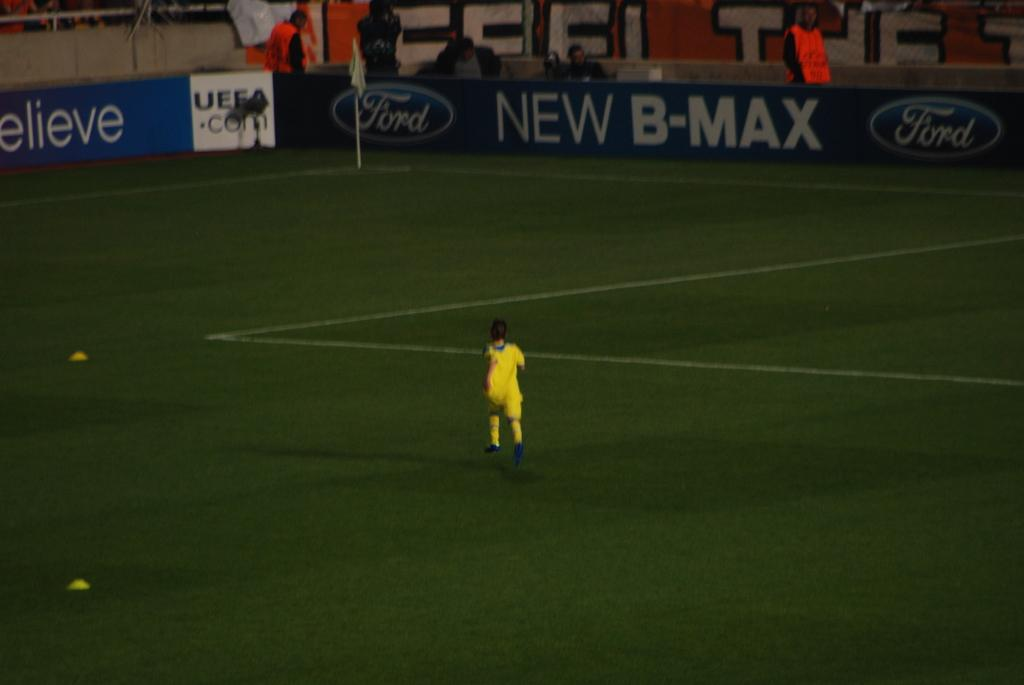<image>
Summarize the visual content of the image. A sign for Ford New B-Max is shown surrounding a field where a  yellow player runs. 